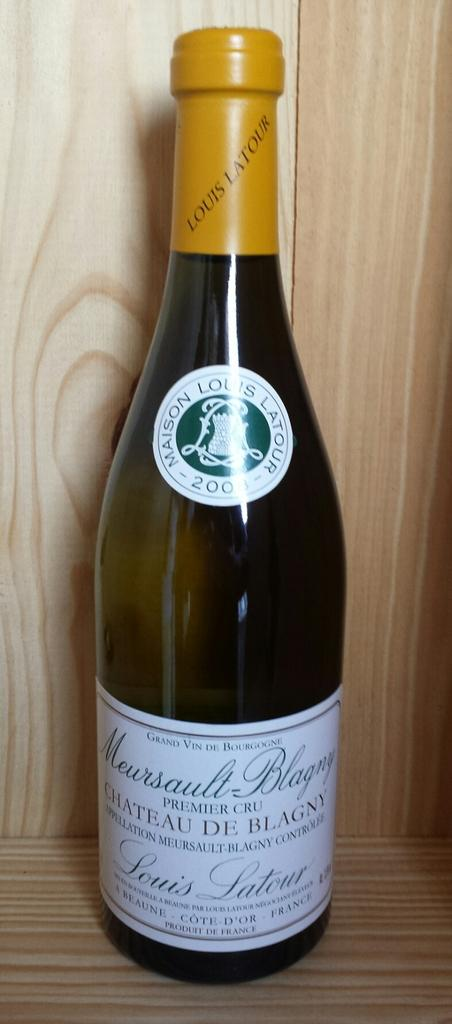<image>
Write a terse but informative summary of the picture. A bottle of Grand Vin de Bourgogne sitting on a wooden shelf. 